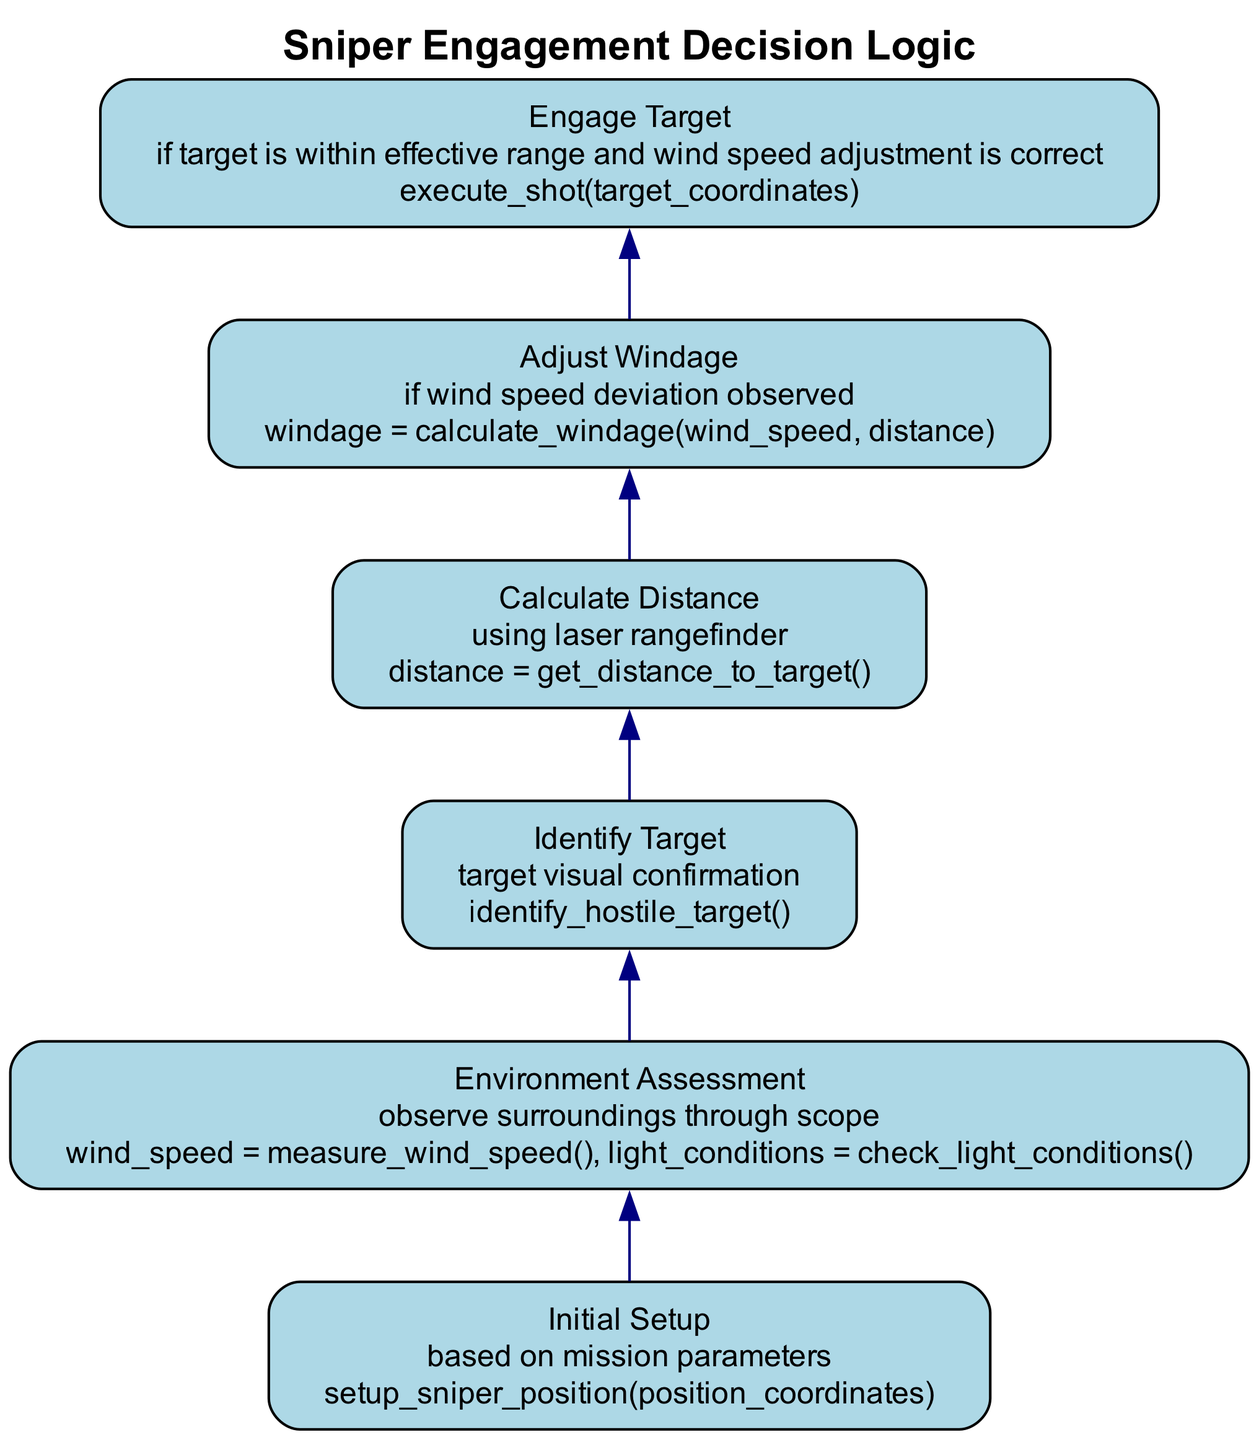What is the first action taken in the process? The first action in the process is determined by the last node in the flowchart, labeled "Initial Setup," which is the first step when reading from bottom to top.
Answer: setup sniper position How many nodes are there in total? The flowchart features six distinct nodes, each representing a specific action or condition related to engaging targets.
Answer: six What condition must be met to engage a target? To engage a target, the flowchart specifies that the target must be within effective range and the wind speed adjustment must be correct. This is indicated in the "Engage Target" node.
Answer: effective range and correct wind speed adjustment What action occurs if a wind speed deviation is observed? If a wind speed deviation is detected, the flowchart indicates that the action taken is to calculate the windage based on the observed wind speed and target distance. This is reflected in the "Adjust Windage" node.
Answer: calculate windage What must be done after identifying a target? After identifying the target, the next logical step is to assess the environment for specific factors such as wind speed and light conditions, as indicated by the "Environment Assessment" node.
Answer: assess the environment What action is taken after calculating distance? Once the distance is calculated using a laser rangefinder, the next logical action is to adjust the windage if a wind speed deviation is observed, as indicated by the connection to the "Adjust Windage" node.
Answer: adjust windage What is the relationship between the "Identify Target" and "Engage Target" nodes? The "Identify Target" node is a prerequisite condition that must be satisfied for moving to the "Engage Target" node, indicating a logical flow from identification to engagement.
Answer: prerequisite condition What does the "Environment Assessment" node measure? The "Environment Assessment" node measures wind speed and checks light conditions through the sniper's scope, indicating the necessary environmental factors to consider before engaging a target.
Answer: wind speed and light conditions What is the last action before engaging a target? Before engaging a target, the last action performed is adjusting the windage based on any observed wind speed deviation, as represented in the flow before the "Engage Target" node.
Answer: adjust windage 